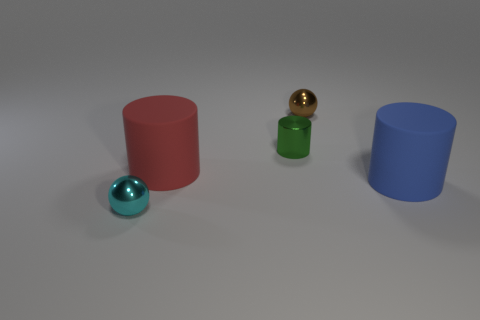How many other objects are the same shape as the small brown object?
Your answer should be compact. 1. What is the shape of the large thing to the right of the red object?
Your answer should be very brief. Cylinder. The small cylinder has what color?
Make the answer very short. Green. What number of other things are there of the same size as the blue rubber thing?
Your answer should be compact. 1. What is the material of the small ball that is on the right side of the metallic ball in front of the shiny cylinder?
Keep it short and to the point. Metal. There is a red thing; is its size the same as the object in front of the large blue thing?
Offer a very short reply. No. How many big objects are green metallic balls or cyan spheres?
Ensure brevity in your answer.  0. How many small green cylinders are there?
Give a very brief answer. 1. What material is the ball in front of the tiny brown metallic object?
Your answer should be compact. Metal. There is a cyan metal thing; are there any red things right of it?
Keep it short and to the point. Yes. 